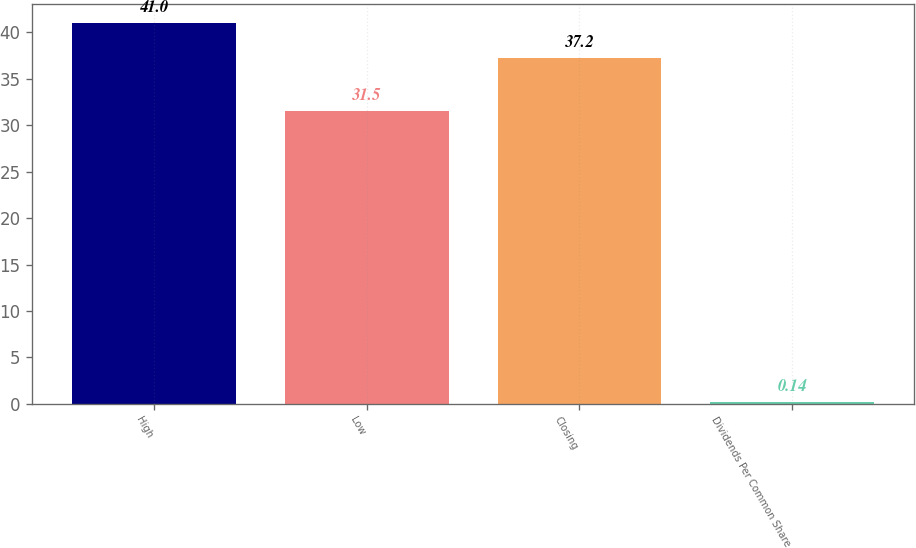<chart> <loc_0><loc_0><loc_500><loc_500><bar_chart><fcel>High<fcel>Low<fcel>Closing<fcel>Dividends Per Common Share<nl><fcel>41<fcel>31.5<fcel>37.2<fcel>0.14<nl></chart> 